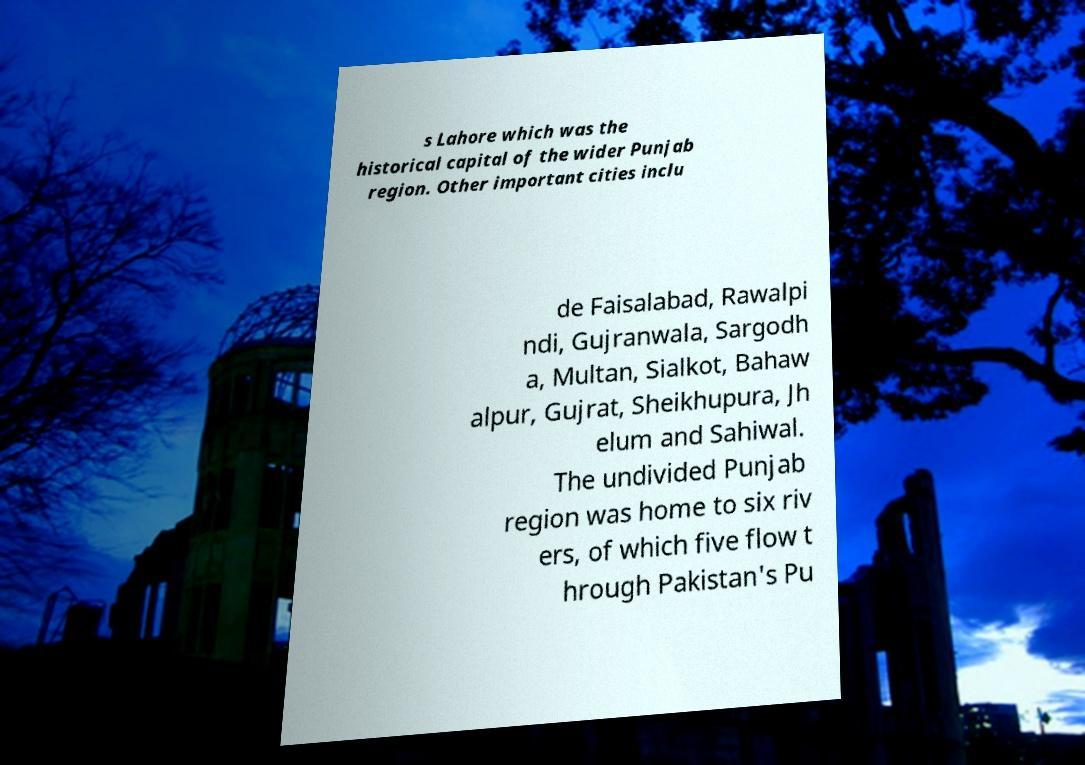Please identify and transcribe the text found in this image. s Lahore which was the historical capital of the wider Punjab region. Other important cities inclu de Faisalabad, Rawalpi ndi, Gujranwala, Sargodh a, Multan, Sialkot, Bahaw alpur, Gujrat, Sheikhupura, Jh elum and Sahiwal. The undivided Punjab region was home to six riv ers, of which five flow t hrough Pakistan's Pu 